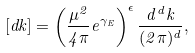Convert formula to latex. <formula><loc_0><loc_0><loc_500><loc_500>[ d k ] = \left ( \frac { \mu ^ { 2 } } { 4 \pi } e ^ { \gamma _ { E } } \right ) ^ { \epsilon } \frac { d ^ { d } k } { ( 2 \pi ) ^ { d } } ,</formula> 